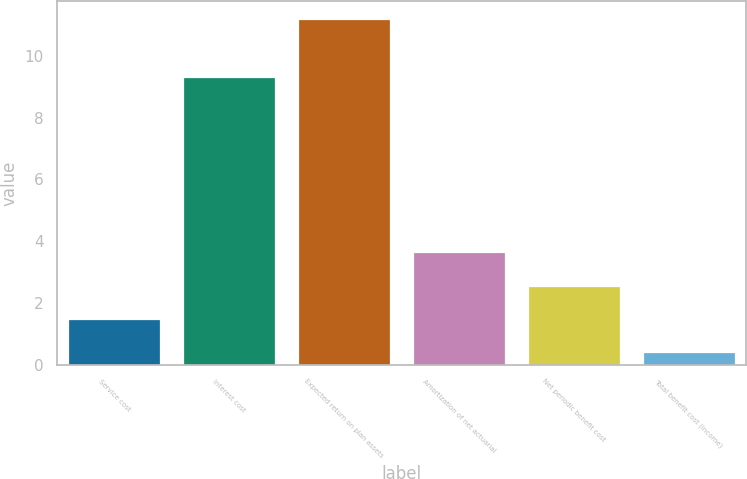Convert chart to OTSL. <chart><loc_0><loc_0><loc_500><loc_500><bar_chart><fcel>Service cost<fcel>Interest cost<fcel>Expected return on plan assets<fcel>Amortization of net actuarial<fcel>Net periodic benefit cost<fcel>Total benefit cost (income)<nl><fcel>1.48<fcel>9.3<fcel>11.2<fcel>3.64<fcel>2.56<fcel>0.4<nl></chart> 